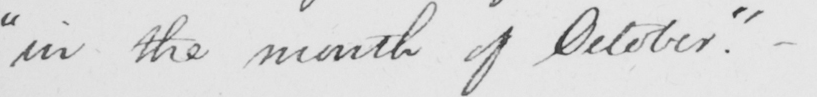What does this handwritten line say? " in the month of October . "   _ 